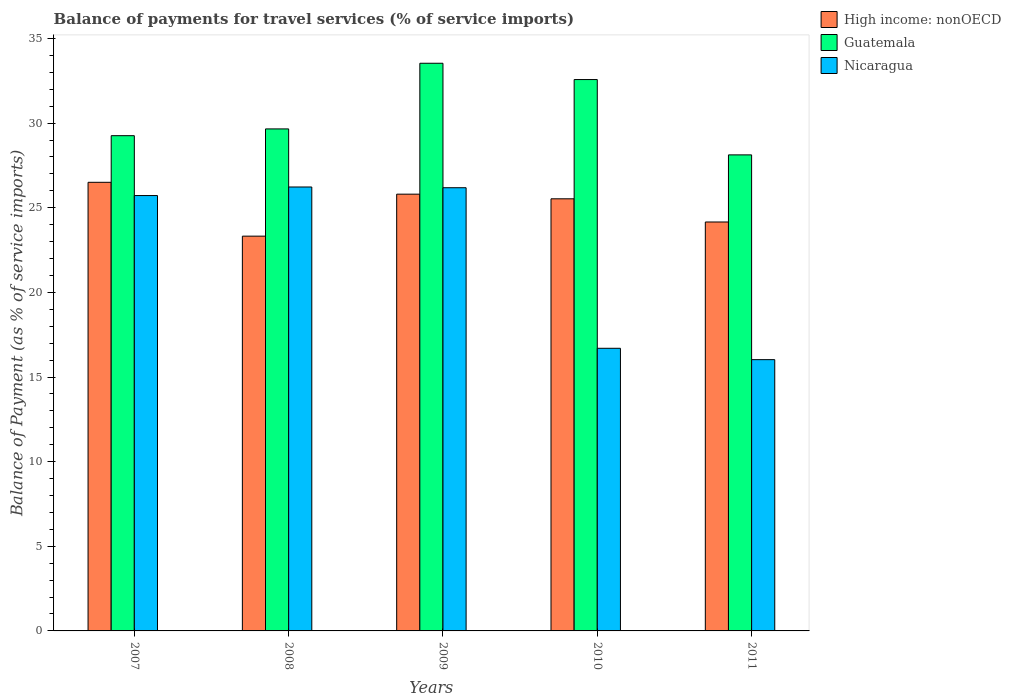How many different coloured bars are there?
Ensure brevity in your answer.  3. Are the number of bars on each tick of the X-axis equal?
Offer a terse response. Yes. How many bars are there on the 3rd tick from the left?
Your answer should be compact. 3. What is the balance of payments for travel services in High income: nonOECD in 2010?
Keep it short and to the point. 25.53. Across all years, what is the maximum balance of payments for travel services in Guatemala?
Your answer should be compact. 33.54. Across all years, what is the minimum balance of payments for travel services in High income: nonOECD?
Offer a very short reply. 23.32. In which year was the balance of payments for travel services in Guatemala minimum?
Provide a succinct answer. 2011. What is the total balance of payments for travel services in Nicaragua in the graph?
Your answer should be compact. 110.85. What is the difference between the balance of payments for travel services in Guatemala in 2007 and that in 2009?
Provide a short and direct response. -4.28. What is the difference between the balance of payments for travel services in Nicaragua in 2007 and the balance of payments for travel services in Guatemala in 2009?
Ensure brevity in your answer.  -7.82. What is the average balance of payments for travel services in Guatemala per year?
Make the answer very short. 30.63. In the year 2010, what is the difference between the balance of payments for travel services in Nicaragua and balance of payments for travel services in Guatemala?
Provide a short and direct response. -15.88. What is the ratio of the balance of payments for travel services in Guatemala in 2008 to that in 2010?
Offer a terse response. 0.91. Is the balance of payments for travel services in High income: nonOECD in 2010 less than that in 2011?
Your answer should be compact. No. What is the difference between the highest and the second highest balance of payments for travel services in Guatemala?
Give a very brief answer. 0.96. What is the difference between the highest and the lowest balance of payments for travel services in Nicaragua?
Keep it short and to the point. 10.2. In how many years, is the balance of payments for travel services in High income: nonOECD greater than the average balance of payments for travel services in High income: nonOECD taken over all years?
Your answer should be very brief. 3. What does the 2nd bar from the left in 2007 represents?
Provide a short and direct response. Guatemala. What does the 3rd bar from the right in 2011 represents?
Make the answer very short. High income: nonOECD. How many bars are there?
Offer a terse response. 15. Are all the bars in the graph horizontal?
Offer a very short reply. No. What is the difference between two consecutive major ticks on the Y-axis?
Your answer should be compact. 5. Are the values on the major ticks of Y-axis written in scientific E-notation?
Ensure brevity in your answer.  No. Does the graph contain any zero values?
Give a very brief answer. No. How many legend labels are there?
Give a very brief answer. 3. What is the title of the graph?
Give a very brief answer. Balance of payments for travel services (% of service imports). Does "Vietnam" appear as one of the legend labels in the graph?
Offer a terse response. No. What is the label or title of the Y-axis?
Your answer should be compact. Balance of Payment (as % of service imports). What is the Balance of Payment (as % of service imports) in High income: nonOECD in 2007?
Keep it short and to the point. 26.5. What is the Balance of Payment (as % of service imports) in Guatemala in 2007?
Your answer should be compact. 29.26. What is the Balance of Payment (as % of service imports) of Nicaragua in 2007?
Offer a terse response. 25.72. What is the Balance of Payment (as % of service imports) of High income: nonOECD in 2008?
Ensure brevity in your answer.  23.32. What is the Balance of Payment (as % of service imports) of Guatemala in 2008?
Your response must be concise. 29.66. What is the Balance of Payment (as % of service imports) in Nicaragua in 2008?
Offer a terse response. 26.23. What is the Balance of Payment (as % of service imports) of High income: nonOECD in 2009?
Your answer should be very brief. 25.8. What is the Balance of Payment (as % of service imports) of Guatemala in 2009?
Give a very brief answer. 33.54. What is the Balance of Payment (as % of service imports) in Nicaragua in 2009?
Make the answer very short. 26.18. What is the Balance of Payment (as % of service imports) in High income: nonOECD in 2010?
Provide a short and direct response. 25.53. What is the Balance of Payment (as % of service imports) of Guatemala in 2010?
Keep it short and to the point. 32.57. What is the Balance of Payment (as % of service imports) of Nicaragua in 2010?
Keep it short and to the point. 16.7. What is the Balance of Payment (as % of service imports) of High income: nonOECD in 2011?
Provide a short and direct response. 24.16. What is the Balance of Payment (as % of service imports) in Guatemala in 2011?
Your answer should be very brief. 28.12. What is the Balance of Payment (as % of service imports) of Nicaragua in 2011?
Give a very brief answer. 16.03. Across all years, what is the maximum Balance of Payment (as % of service imports) of High income: nonOECD?
Keep it short and to the point. 26.5. Across all years, what is the maximum Balance of Payment (as % of service imports) in Guatemala?
Offer a very short reply. 33.54. Across all years, what is the maximum Balance of Payment (as % of service imports) in Nicaragua?
Keep it short and to the point. 26.23. Across all years, what is the minimum Balance of Payment (as % of service imports) of High income: nonOECD?
Your answer should be compact. 23.32. Across all years, what is the minimum Balance of Payment (as % of service imports) in Guatemala?
Your answer should be compact. 28.12. Across all years, what is the minimum Balance of Payment (as % of service imports) in Nicaragua?
Your answer should be very brief. 16.03. What is the total Balance of Payment (as % of service imports) in High income: nonOECD in the graph?
Make the answer very short. 125.31. What is the total Balance of Payment (as % of service imports) in Guatemala in the graph?
Provide a succinct answer. 153.14. What is the total Balance of Payment (as % of service imports) of Nicaragua in the graph?
Make the answer very short. 110.85. What is the difference between the Balance of Payment (as % of service imports) of High income: nonOECD in 2007 and that in 2008?
Give a very brief answer. 3.18. What is the difference between the Balance of Payment (as % of service imports) in Guatemala in 2007 and that in 2008?
Ensure brevity in your answer.  -0.4. What is the difference between the Balance of Payment (as % of service imports) in Nicaragua in 2007 and that in 2008?
Offer a terse response. -0.51. What is the difference between the Balance of Payment (as % of service imports) in High income: nonOECD in 2007 and that in 2009?
Your response must be concise. 0.7. What is the difference between the Balance of Payment (as % of service imports) of Guatemala in 2007 and that in 2009?
Offer a very short reply. -4.28. What is the difference between the Balance of Payment (as % of service imports) of Nicaragua in 2007 and that in 2009?
Offer a very short reply. -0.46. What is the difference between the Balance of Payment (as % of service imports) in High income: nonOECD in 2007 and that in 2010?
Provide a short and direct response. 0.98. What is the difference between the Balance of Payment (as % of service imports) of Guatemala in 2007 and that in 2010?
Your response must be concise. -3.32. What is the difference between the Balance of Payment (as % of service imports) of Nicaragua in 2007 and that in 2010?
Your response must be concise. 9.02. What is the difference between the Balance of Payment (as % of service imports) in High income: nonOECD in 2007 and that in 2011?
Provide a short and direct response. 2.34. What is the difference between the Balance of Payment (as % of service imports) in Guatemala in 2007 and that in 2011?
Give a very brief answer. 1.13. What is the difference between the Balance of Payment (as % of service imports) in Nicaragua in 2007 and that in 2011?
Your answer should be very brief. 9.69. What is the difference between the Balance of Payment (as % of service imports) in High income: nonOECD in 2008 and that in 2009?
Offer a terse response. -2.48. What is the difference between the Balance of Payment (as % of service imports) of Guatemala in 2008 and that in 2009?
Ensure brevity in your answer.  -3.88. What is the difference between the Balance of Payment (as % of service imports) of Nicaragua in 2008 and that in 2009?
Provide a short and direct response. 0.04. What is the difference between the Balance of Payment (as % of service imports) in High income: nonOECD in 2008 and that in 2010?
Your response must be concise. -2.21. What is the difference between the Balance of Payment (as % of service imports) in Guatemala in 2008 and that in 2010?
Offer a very short reply. -2.92. What is the difference between the Balance of Payment (as % of service imports) of Nicaragua in 2008 and that in 2010?
Make the answer very short. 9.53. What is the difference between the Balance of Payment (as % of service imports) of High income: nonOECD in 2008 and that in 2011?
Give a very brief answer. -0.84. What is the difference between the Balance of Payment (as % of service imports) in Guatemala in 2008 and that in 2011?
Offer a very short reply. 1.53. What is the difference between the Balance of Payment (as % of service imports) of Nicaragua in 2008 and that in 2011?
Provide a succinct answer. 10.2. What is the difference between the Balance of Payment (as % of service imports) in High income: nonOECD in 2009 and that in 2010?
Offer a very short reply. 0.27. What is the difference between the Balance of Payment (as % of service imports) in Guatemala in 2009 and that in 2010?
Your answer should be compact. 0.96. What is the difference between the Balance of Payment (as % of service imports) of Nicaragua in 2009 and that in 2010?
Offer a terse response. 9.48. What is the difference between the Balance of Payment (as % of service imports) in High income: nonOECD in 2009 and that in 2011?
Keep it short and to the point. 1.64. What is the difference between the Balance of Payment (as % of service imports) of Guatemala in 2009 and that in 2011?
Your answer should be very brief. 5.41. What is the difference between the Balance of Payment (as % of service imports) of Nicaragua in 2009 and that in 2011?
Offer a very short reply. 10.16. What is the difference between the Balance of Payment (as % of service imports) of High income: nonOECD in 2010 and that in 2011?
Give a very brief answer. 1.37. What is the difference between the Balance of Payment (as % of service imports) of Guatemala in 2010 and that in 2011?
Your response must be concise. 4.45. What is the difference between the Balance of Payment (as % of service imports) of Nicaragua in 2010 and that in 2011?
Provide a short and direct response. 0.67. What is the difference between the Balance of Payment (as % of service imports) in High income: nonOECD in 2007 and the Balance of Payment (as % of service imports) in Guatemala in 2008?
Make the answer very short. -3.15. What is the difference between the Balance of Payment (as % of service imports) of High income: nonOECD in 2007 and the Balance of Payment (as % of service imports) of Nicaragua in 2008?
Offer a very short reply. 0.28. What is the difference between the Balance of Payment (as % of service imports) of Guatemala in 2007 and the Balance of Payment (as % of service imports) of Nicaragua in 2008?
Make the answer very short. 3.03. What is the difference between the Balance of Payment (as % of service imports) in High income: nonOECD in 2007 and the Balance of Payment (as % of service imports) in Guatemala in 2009?
Offer a terse response. -7.03. What is the difference between the Balance of Payment (as % of service imports) of High income: nonOECD in 2007 and the Balance of Payment (as % of service imports) of Nicaragua in 2009?
Your answer should be compact. 0.32. What is the difference between the Balance of Payment (as % of service imports) of Guatemala in 2007 and the Balance of Payment (as % of service imports) of Nicaragua in 2009?
Keep it short and to the point. 3.08. What is the difference between the Balance of Payment (as % of service imports) of High income: nonOECD in 2007 and the Balance of Payment (as % of service imports) of Guatemala in 2010?
Give a very brief answer. -6.07. What is the difference between the Balance of Payment (as % of service imports) in High income: nonOECD in 2007 and the Balance of Payment (as % of service imports) in Nicaragua in 2010?
Give a very brief answer. 9.81. What is the difference between the Balance of Payment (as % of service imports) of Guatemala in 2007 and the Balance of Payment (as % of service imports) of Nicaragua in 2010?
Ensure brevity in your answer.  12.56. What is the difference between the Balance of Payment (as % of service imports) in High income: nonOECD in 2007 and the Balance of Payment (as % of service imports) in Guatemala in 2011?
Keep it short and to the point. -1.62. What is the difference between the Balance of Payment (as % of service imports) of High income: nonOECD in 2007 and the Balance of Payment (as % of service imports) of Nicaragua in 2011?
Make the answer very short. 10.48. What is the difference between the Balance of Payment (as % of service imports) in Guatemala in 2007 and the Balance of Payment (as % of service imports) in Nicaragua in 2011?
Offer a terse response. 13.23. What is the difference between the Balance of Payment (as % of service imports) in High income: nonOECD in 2008 and the Balance of Payment (as % of service imports) in Guatemala in 2009?
Provide a short and direct response. -10.21. What is the difference between the Balance of Payment (as % of service imports) in High income: nonOECD in 2008 and the Balance of Payment (as % of service imports) in Nicaragua in 2009?
Give a very brief answer. -2.86. What is the difference between the Balance of Payment (as % of service imports) in Guatemala in 2008 and the Balance of Payment (as % of service imports) in Nicaragua in 2009?
Your answer should be very brief. 3.47. What is the difference between the Balance of Payment (as % of service imports) of High income: nonOECD in 2008 and the Balance of Payment (as % of service imports) of Guatemala in 2010?
Offer a terse response. -9.25. What is the difference between the Balance of Payment (as % of service imports) of High income: nonOECD in 2008 and the Balance of Payment (as % of service imports) of Nicaragua in 2010?
Offer a terse response. 6.62. What is the difference between the Balance of Payment (as % of service imports) in Guatemala in 2008 and the Balance of Payment (as % of service imports) in Nicaragua in 2010?
Offer a very short reply. 12.96. What is the difference between the Balance of Payment (as % of service imports) of High income: nonOECD in 2008 and the Balance of Payment (as % of service imports) of Guatemala in 2011?
Keep it short and to the point. -4.8. What is the difference between the Balance of Payment (as % of service imports) of High income: nonOECD in 2008 and the Balance of Payment (as % of service imports) of Nicaragua in 2011?
Keep it short and to the point. 7.3. What is the difference between the Balance of Payment (as % of service imports) of Guatemala in 2008 and the Balance of Payment (as % of service imports) of Nicaragua in 2011?
Your answer should be very brief. 13.63. What is the difference between the Balance of Payment (as % of service imports) of High income: nonOECD in 2009 and the Balance of Payment (as % of service imports) of Guatemala in 2010?
Give a very brief answer. -6.77. What is the difference between the Balance of Payment (as % of service imports) of High income: nonOECD in 2009 and the Balance of Payment (as % of service imports) of Nicaragua in 2010?
Provide a succinct answer. 9.11. What is the difference between the Balance of Payment (as % of service imports) in Guatemala in 2009 and the Balance of Payment (as % of service imports) in Nicaragua in 2010?
Offer a very short reply. 16.84. What is the difference between the Balance of Payment (as % of service imports) in High income: nonOECD in 2009 and the Balance of Payment (as % of service imports) in Guatemala in 2011?
Your response must be concise. -2.32. What is the difference between the Balance of Payment (as % of service imports) of High income: nonOECD in 2009 and the Balance of Payment (as % of service imports) of Nicaragua in 2011?
Make the answer very short. 9.78. What is the difference between the Balance of Payment (as % of service imports) in Guatemala in 2009 and the Balance of Payment (as % of service imports) in Nicaragua in 2011?
Ensure brevity in your answer.  17.51. What is the difference between the Balance of Payment (as % of service imports) in High income: nonOECD in 2010 and the Balance of Payment (as % of service imports) in Guatemala in 2011?
Your answer should be very brief. -2.6. What is the difference between the Balance of Payment (as % of service imports) in High income: nonOECD in 2010 and the Balance of Payment (as % of service imports) in Nicaragua in 2011?
Offer a very short reply. 9.5. What is the difference between the Balance of Payment (as % of service imports) in Guatemala in 2010 and the Balance of Payment (as % of service imports) in Nicaragua in 2011?
Give a very brief answer. 16.55. What is the average Balance of Payment (as % of service imports) in High income: nonOECD per year?
Provide a succinct answer. 25.06. What is the average Balance of Payment (as % of service imports) in Guatemala per year?
Keep it short and to the point. 30.63. What is the average Balance of Payment (as % of service imports) in Nicaragua per year?
Provide a succinct answer. 22.17. In the year 2007, what is the difference between the Balance of Payment (as % of service imports) of High income: nonOECD and Balance of Payment (as % of service imports) of Guatemala?
Make the answer very short. -2.75. In the year 2007, what is the difference between the Balance of Payment (as % of service imports) of High income: nonOECD and Balance of Payment (as % of service imports) of Nicaragua?
Your answer should be compact. 0.78. In the year 2007, what is the difference between the Balance of Payment (as % of service imports) of Guatemala and Balance of Payment (as % of service imports) of Nicaragua?
Provide a short and direct response. 3.54. In the year 2008, what is the difference between the Balance of Payment (as % of service imports) in High income: nonOECD and Balance of Payment (as % of service imports) in Guatemala?
Keep it short and to the point. -6.33. In the year 2008, what is the difference between the Balance of Payment (as % of service imports) of High income: nonOECD and Balance of Payment (as % of service imports) of Nicaragua?
Provide a short and direct response. -2.9. In the year 2008, what is the difference between the Balance of Payment (as % of service imports) in Guatemala and Balance of Payment (as % of service imports) in Nicaragua?
Your response must be concise. 3.43. In the year 2009, what is the difference between the Balance of Payment (as % of service imports) of High income: nonOECD and Balance of Payment (as % of service imports) of Guatemala?
Offer a very short reply. -7.73. In the year 2009, what is the difference between the Balance of Payment (as % of service imports) of High income: nonOECD and Balance of Payment (as % of service imports) of Nicaragua?
Offer a very short reply. -0.38. In the year 2009, what is the difference between the Balance of Payment (as % of service imports) in Guatemala and Balance of Payment (as % of service imports) in Nicaragua?
Ensure brevity in your answer.  7.35. In the year 2010, what is the difference between the Balance of Payment (as % of service imports) of High income: nonOECD and Balance of Payment (as % of service imports) of Guatemala?
Ensure brevity in your answer.  -7.05. In the year 2010, what is the difference between the Balance of Payment (as % of service imports) of High income: nonOECD and Balance of Payment (as % of service imports) of Nicaragua?
Offer a very short reply. 8.83. In the year 2010, what is the difference between the Balance of Payment (as % of service imports) of Guatemala and Balance of Payment (as % of service imports) of Nicaragua?
Ensure brevity in your answer.  15.88. In the year 2011, what is the difference between the Balance of Payment (as % of service imports) of High income: nonOECD and Balance of Payment (as % of service imports) of Guatemala?
Give a very brief answer. -3.96. In the year 2011, what is the difference between the Balance of Payment (as % of service imports) of High income: nonOECD and Balance of Payment (as % of service imports) of Nicaragua?
Your answer should be compact. 8.13. In the year 2011, what is the difference between the Balance of Payment (as % of service imports) in Guatemala and Balance of Payment (as % of service imports) in Nicaragua?
Ensure brevity in your answer.  12.1. What is the ratio of the Balance of Payment (as % of service imports) in High income: nonOECD in 2007 to that in 2008?
Keep it short and to the point. 1.14. What is the ratio of the Balance of Payment (as % of service imports) in Guatemala in 2007 to that in 2008?
Offer a very short reply. 0.99. What is the ratio of the Balance of Payment (as % of service imports) of Nicaragua in 2007 to that in 2008?
Ensure brevity in your answer.  0.98. What is the ratio of the Balance of Payment (as % of service imports) in High income: nonOECD in 2007 to that in 2009?
Ensure brevity in your answer.  1.03. What is the ratio of the Balance of Payment (as % of service imports) in Guatemala in 2007 to that in 2009?
Offer a terse response. 0.87. What is the ratio of the Balance of Payment (as % of service imports) in Nicaragua in 2007 to that in 2009?
Your response must be concise. 0.98. What is the ratio of the Balance of Payment (as % of service imports) in High income: nonOECD in 2007 to that in 2010?
Provide a succinct answer. 1.04. What is the ratio of the Balance of Payment (as % of service imports) of Guatemala in 2007 to that in 2010?
Ensure brevity in your answer.  0.9. What is the ratio of the Balance of Payment (as % of service imports) of Nicaragua in 2007 to that in 2010?
Make the answer very short. 1.54. What is the ratio of the Balance of Payment (as % of service imports) of High income: nonOECD in 2007 to that in 2011?
Offer a terse response. 1.1. What is the ratio of the Balance of Payment (as % of service imports) in Guatemala in 2007 to that in 2011?
Make the answer very short. 1.04. What is the ratio of the Balance of Payment (as % of service imports) in Nicaragua in 2007 to that in 2011?
Your answer should be compact. 1.6. What is the ratio of the Balance of Payment (as % of service imports) of High income: nonOECD in 2008 to that in 2009?
Provide a succinct answer. 0.9. What is the ratio of the Balance of Payment (as % of service imports) in Guatemala in 2008 to that in 2009?
Your answer should be compact. 0.88. What is the ratio of the Balance of Payment (as % of service imports) in High income: nonOECD in 2008 to that in 2010?
Offer a very short reply. 0.91. What is the ratio of the Balance of Payment (as % of service imports) in Guatemala in 2008 to that in 2010?
Keep it short and to the point. 0.91. What is the ratio of the Balance of Payment (as % of service imports) in Nicaragua in 2008 to that in 2010?
Provide a short and direct response. 1.57. What is the ratio of the Balance of Payment (as % of service imports) in High income: nonOECD in 2008 to that in 2011?
Keep it short and to the point. 0.97. What is the ratio of the Balance of Payment (as % of service imports) of Guatemala in 2008 to that in 2011?
Make the answer very short. 1.05. What is the ratio of the Balance of Payment (as % of service imports) in Nicaragua in 2008 to that in 2011?
Offer a terse response. 1.64. What is the ratio of the Balance of Payment (as % of service imports) of High income: nonOECD in 2009 to that in 2010?
Your answer should be compact. 1.01. What is the ratio of the Balance of Payment (as % of service imports) of Guatemala in 2009 to that in 2010?
Keep it short and to the point. 1.03. What is the ratio of the Balance of Payment (as % of service imports) of Nicaragua in 2009 to that in 2010?
Give a very brief answer. 1.57. What is the ratio of the Balance of Payment (as % of service imports) in High income: nonOECD in 2009 to that in 2011?
Offer a terse response. 1.07. What is the ratio of the Balance of Payment (as % of service imports) in Guatemala in 2009 to that in 2011?
Ensure brevity in your answer.  1.19. What is the ratio of the Balance of Payment (as % of service imports) in Nicaragua in 2009 to that in 2011?
Your answer should be very brief. 1.63. What is the ratio of the Balance of Payment (as % of service imports) in High income: nonOECD in 2010 to that in 2011?
Provide a short and direct response. 1.06. What is the ratio of the Balance of Payment (as % of service imports) in Guatemala in 2010 to that in 2011?
Keep it short and to the point. 1.16. What is the ratio of the Balance of Payment (as % of service imports) of Nicaragua in 2010 to that in 2011?
Your response must be concise. 1.04. What is the difference between the highest and the second highest Balance of Payment (as % of service imports) in High income: nonOECD?
Give a very brief answer. 0.7. What is the difference between the highest and the second highest Balance of Payment (as % of service imports) of Guatemala?
Offer a very short reply. 0.96. What is the difference between the highest and the second highest Balance of Payment (as % of service imports) in Nicaragua?
Your answer should be very brief. 0.04. What is the difference between the highest and the lowest Balance of Payment (as % of service imports) of High income: nonOECD?
Provide a succinct answer. 3.18. What is the difference between the highest and the lowest Balance of Payment (as % of service imports) of Guatemala?
Give a very brief answer. 5.41. What is the difference between the highest and the lowest Balance of Payment (as % of service imports) of Nicaragua?
Your answer should be compact. 10.2. 